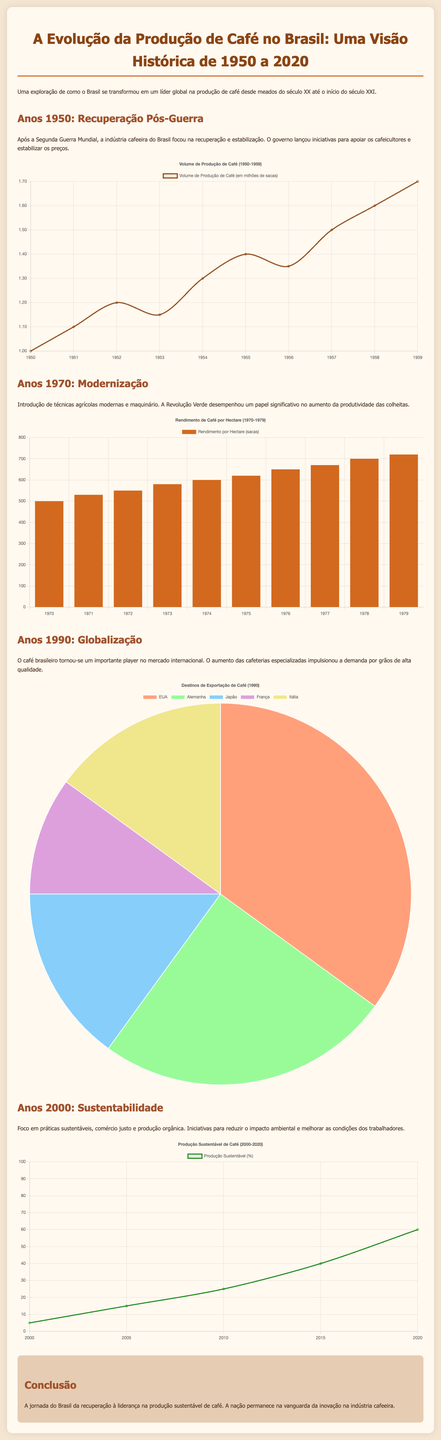What was the volume of coffee production in 1955? The volume of coffee production in 1955 is represented by the data point for that year in the chart, which indicates 1.4 million sacks.
Answer: 1.4 million sacks What major agricultural change occurred in the 1970s? The chart for the 1970s highlights the introduction of modern agricultural techniques that increased productivity, part of the broader Green Revolution.
Answer: Modernization What percentage of sustainable coffee production was reached in 2020? The chart for the 2000s shows that by 2020, sustainable coffee production reached 60%.
Answer: 60% Which country was the largest destination for Brazilian coffee exports in 1990? The pie chart indicates the largest share of coffee exports went to the USA in 1990, making it the leading destination.
Answer: USA What was the average yield per hectare in 1975? The bar chart for the 1970s shows the yield per hectare for 1975 was 620 sacks.
Answer: 620 sacks What trend can be observed from the 2000s chart regarding sustainable coffee production? The line chart indicates a clear upward trend in sustainable coffee production percentage from 2000 to 2020.
Answer: Upward trend How many years are covered in the document? The document covers coffee production in Brazil from 1950 to 2020, spanning a total of 70 years.
Answer: 70 years What does the title of the infographic highlight about Brazil's coffee production? The title emphasizes the historical overview of Brazil as a leader in coffee production from 1950 to 2020.
Answer: Leader in coffee production 